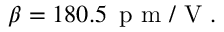<formula> <loc_0><loc_0><loc_500><loc_500>\beta = 1 8 0 . 5 \, p m / V .</formula> 